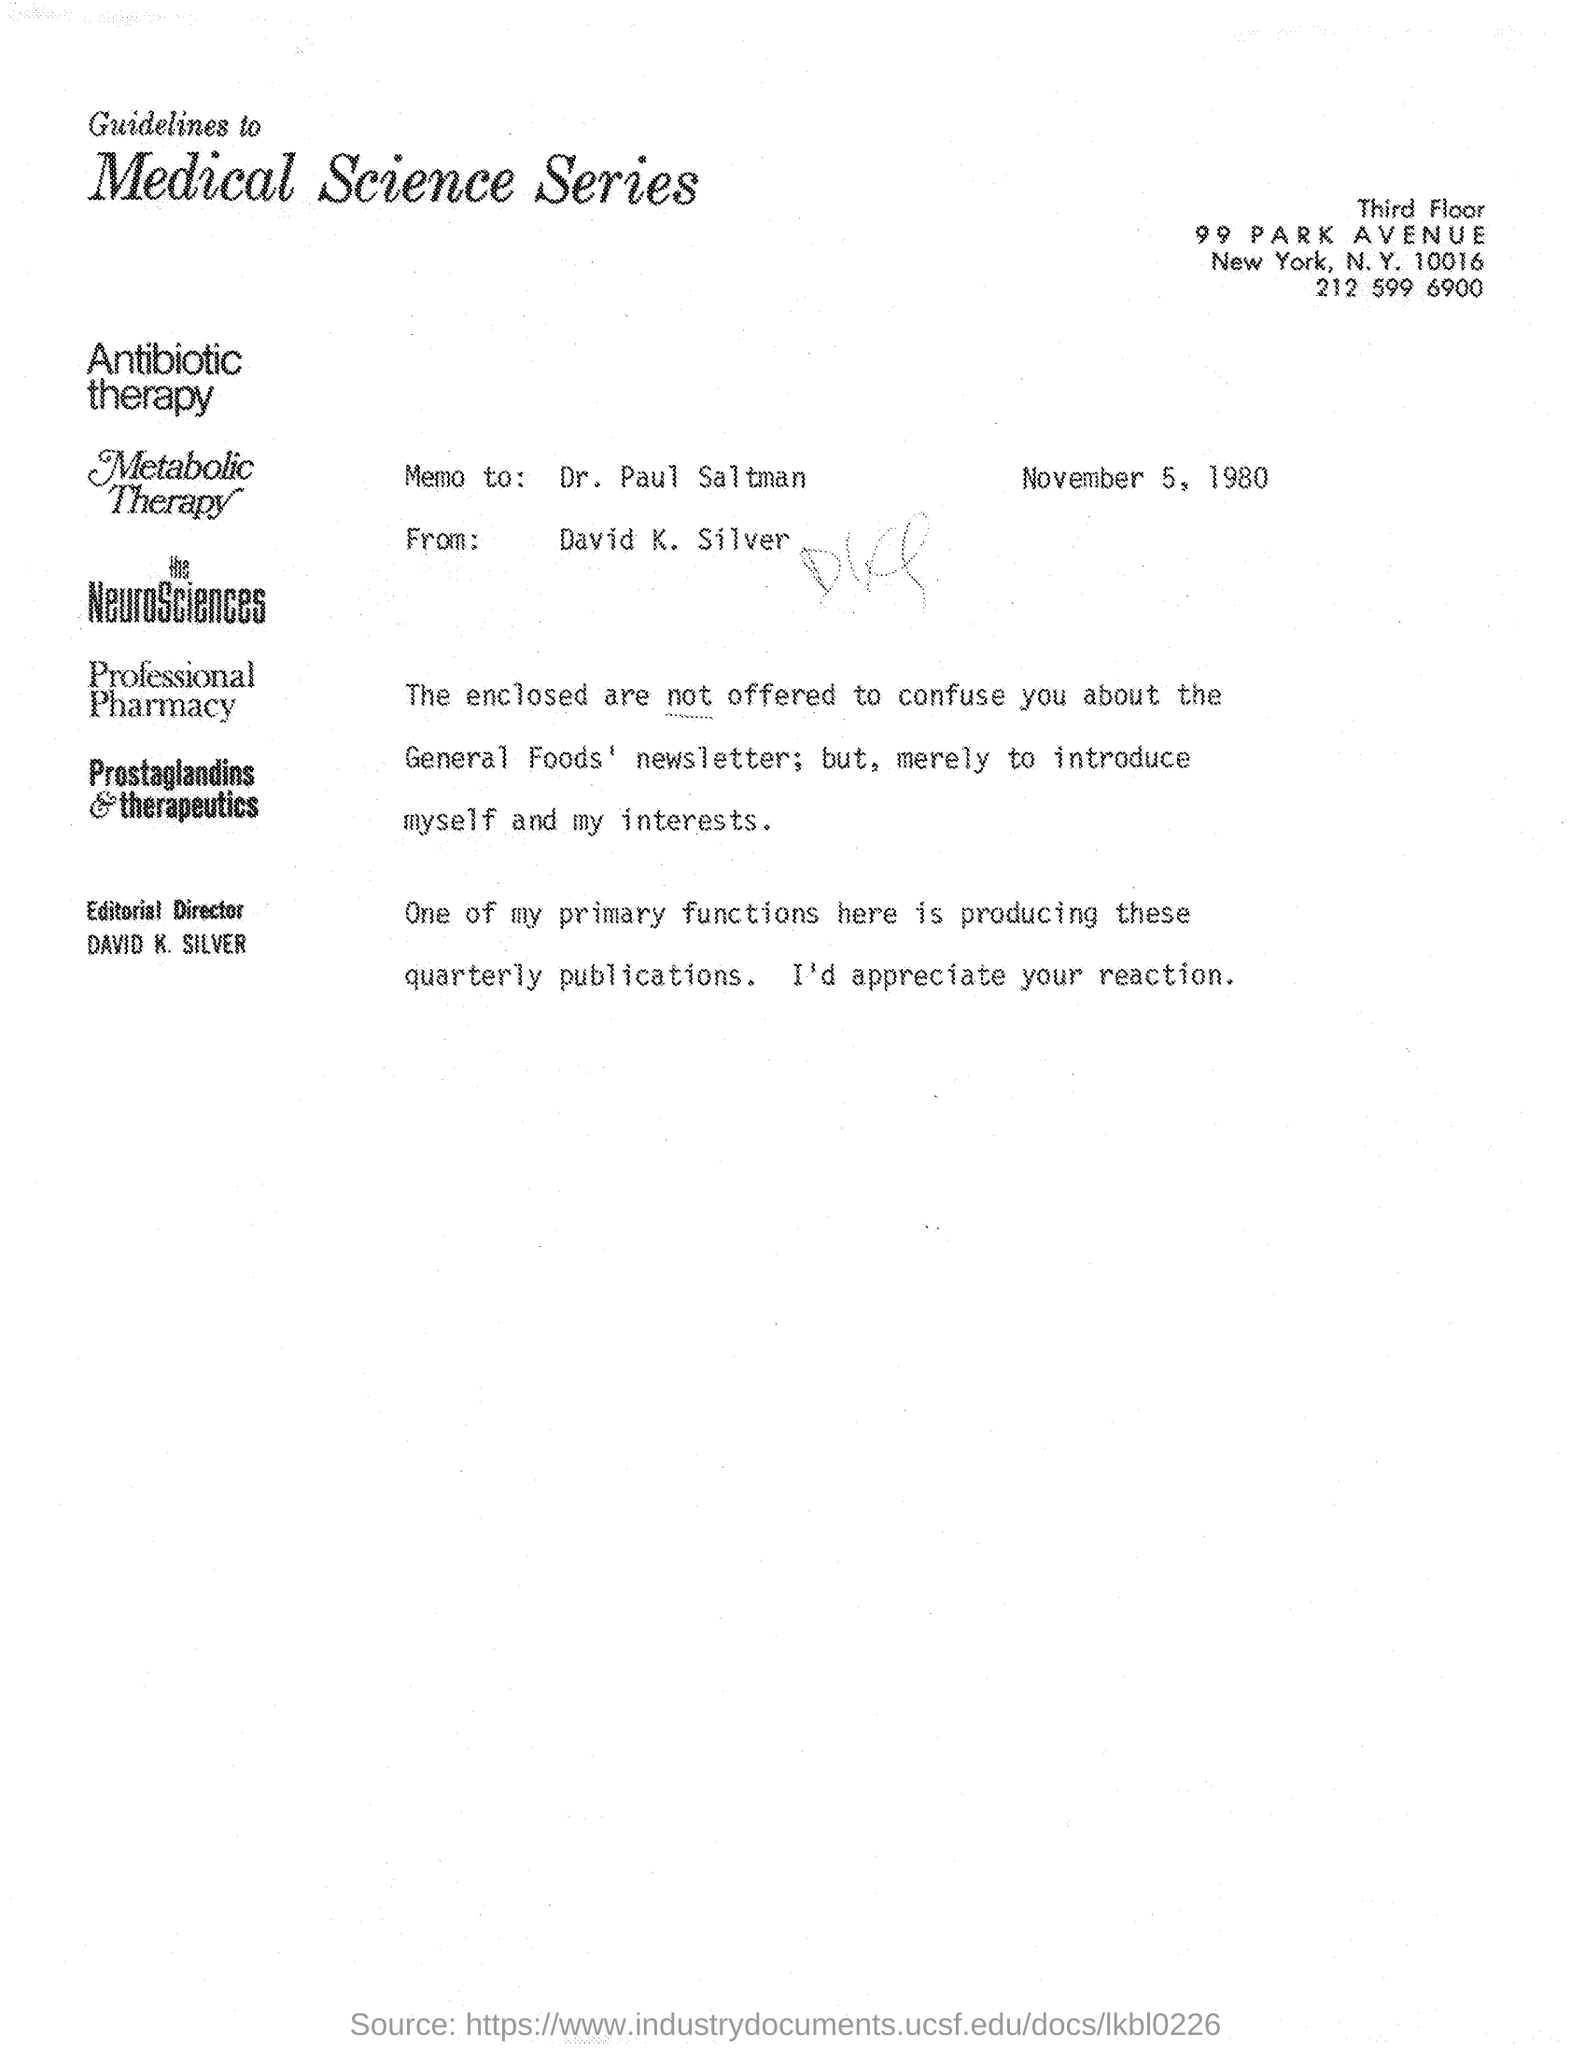List a handful of essential elements in this visual. The memo was received from David K. Silver. The memo was given to Dr. Paul Saltman, as mentioned in the provided page. The editorial director's name, as mentioned on the given page, is David K. Silver. The date mentioned in the given page is November 5, 1980. 